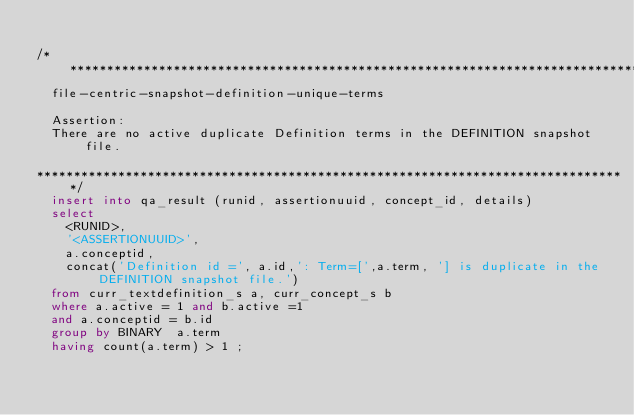Convert code to text. <code><loc_0><loc_0><loc_500><loc_500><_SQL_>
/******************************************************************************** 
	file-centric-snapshot-definition-unique-terms

	Assertion:
	There are no active duplicate Definition terms in the DEFINITION snapshot file.

********************************************************************************/
	insert into qa_result (runid, assertionuuid, concept_id, details)
	select 
		<RUNID>,
		'<ASSERTIONUUID>',
		a.conceptid,
		concat('Definition id =', a.id,': Term=[',a.term, '] is duplicate in the DEFINITION snapshot file.') 	
	from curr_textdefinition_s a, curr_concept_s b
	where a.active = 1 and b.active =1
	and a.conceptid = b.id
	group by BINARY  a.term
	having count(a.term) > 1 ;</code> 